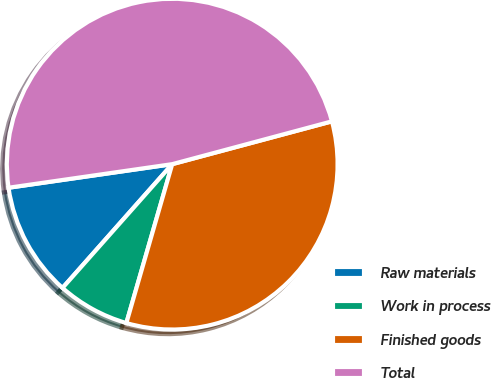<chart> <loc_0><loc_0><loc_500><loc_500><pie_chart><fcel>Raw materials<fcel>Work in process<fcel>Finished goods<fcel>Total<nl><fcel>11.18%<fcel>7.07%<fcel>33.64%<fcel>48.11%<nl></chart> 